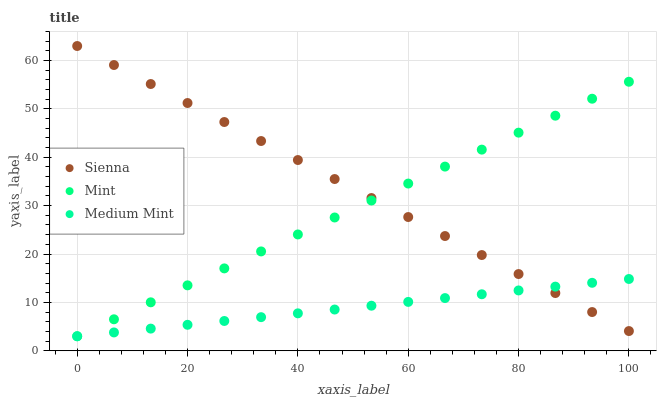Does Medium Mint have the minimum area under the curve?
Answer yes or no. Yes. Does Sienna have the maximum area under the curve?
Answer yes or no. Yes. Does Mint have the minimum area under the curve?
Answer yes or no. No. Does Mint have the maximum area under the curve?
Answer yes or no. No. Is Medium Mint the smoothest?
Answer yes or no. Yes. Is Sienna the roughest?
Answer yes or no. Yes. Is Mint the smoothest?
Answer yes or no. No. Is Mint the roughest?
Answer yes or no. No. Does Medium Mint have the lowest value?
Answer yes or no. Yes. Does Sienna have the highest value?
Answer yes or no. Yes. Does Mint have the highest value?
Answer yes or no. No. Does Medium Mint intersect Sienna?
Answer yes or no. Yes. Is Medium Mint less than Sienna?
Answer yes or no. No. Is Medium Mint greater than Sienna?
Answer yes or no. No. 